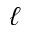<formula> <loc_0><loc_0><loc_500><loc_500>\ell</formula> 